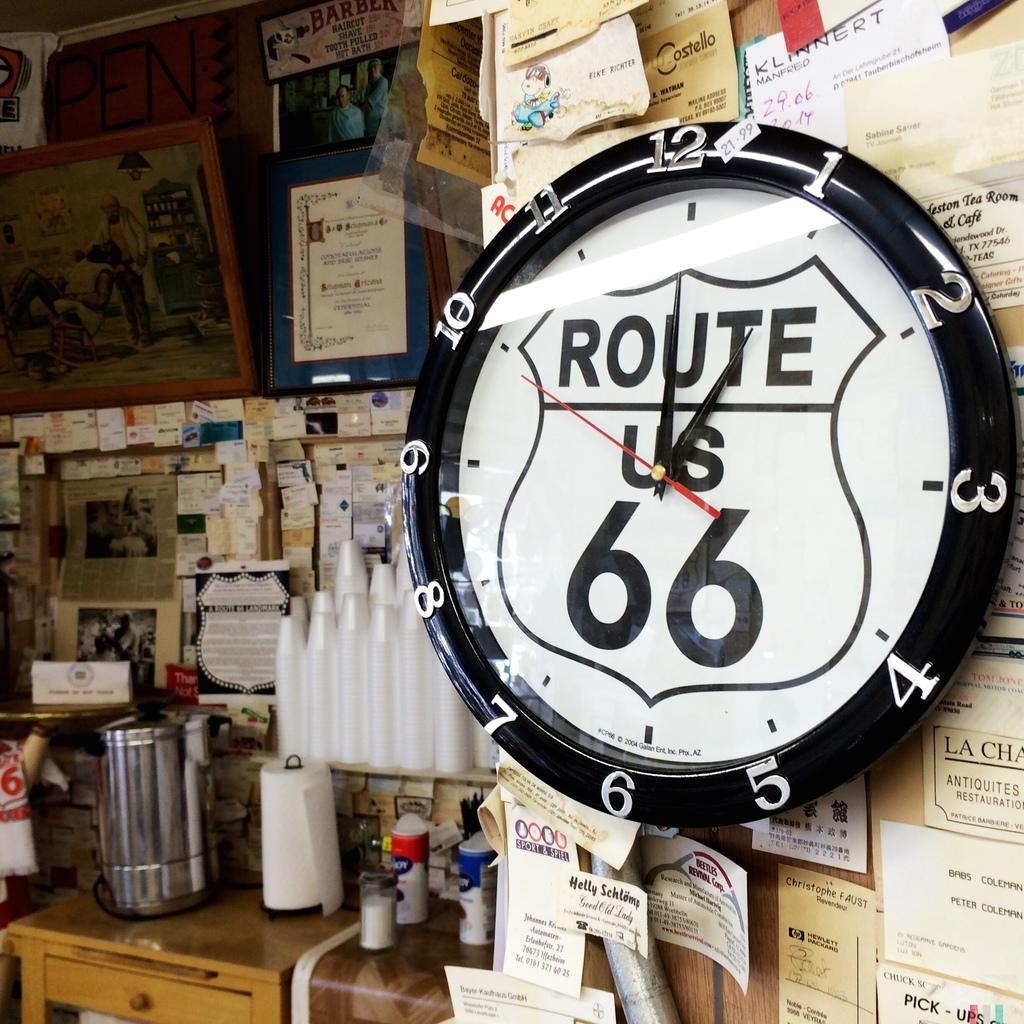<image>
Summarize the visual content of the image. a wall clock with Route US 66 on it is on an announcement board 